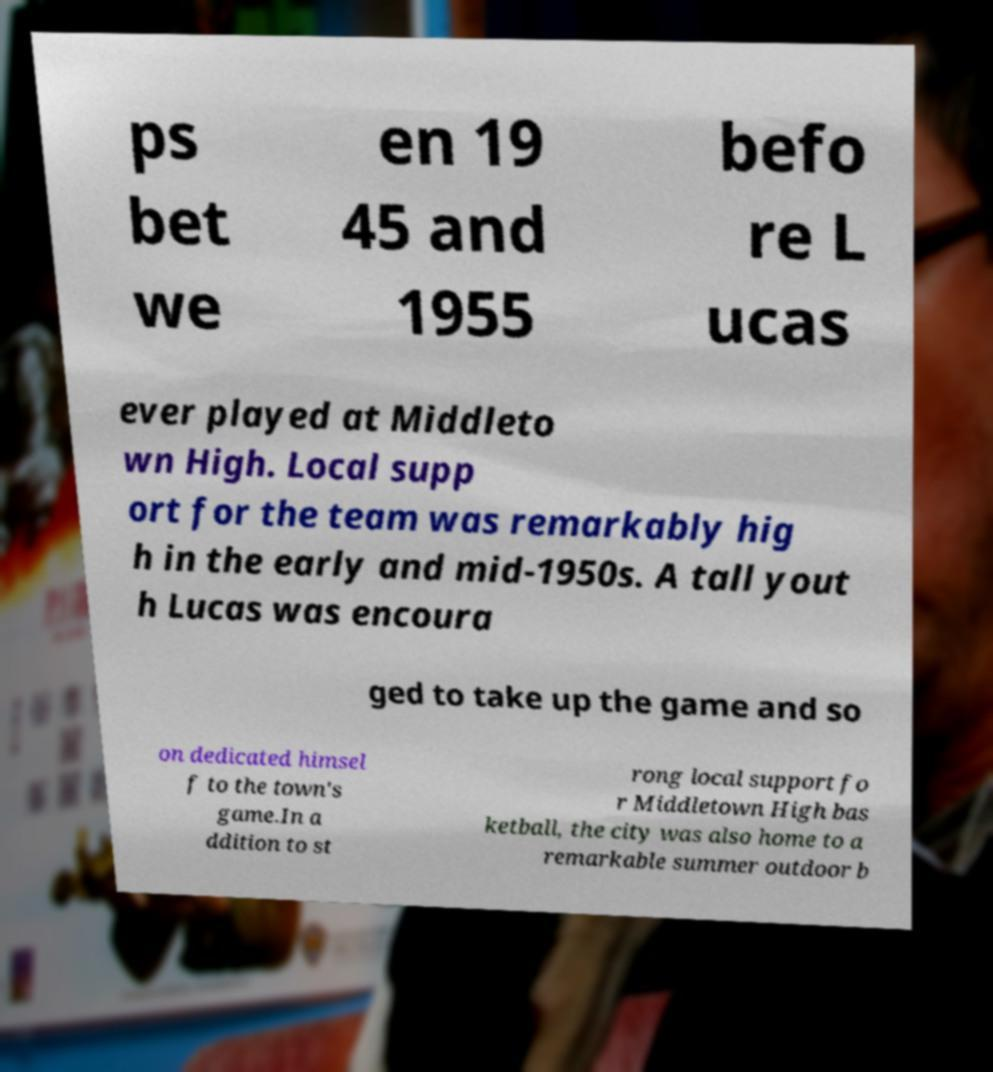Please read and relay the text visible in this image. What does it say? ps bet we en 19 45 and 1955 befo re L ucas ever played at Middleto wn High. Local supp ort for the team was remarkably hig h in the early and mid-1950s. A tall yout h Lucas was encoura ged to take up the game and so on dedicated himsel f to the town's game.In a ddition to st rong local support fo r Middletown High bas ketball, the city was also home to a remarkable summer outdoor b 